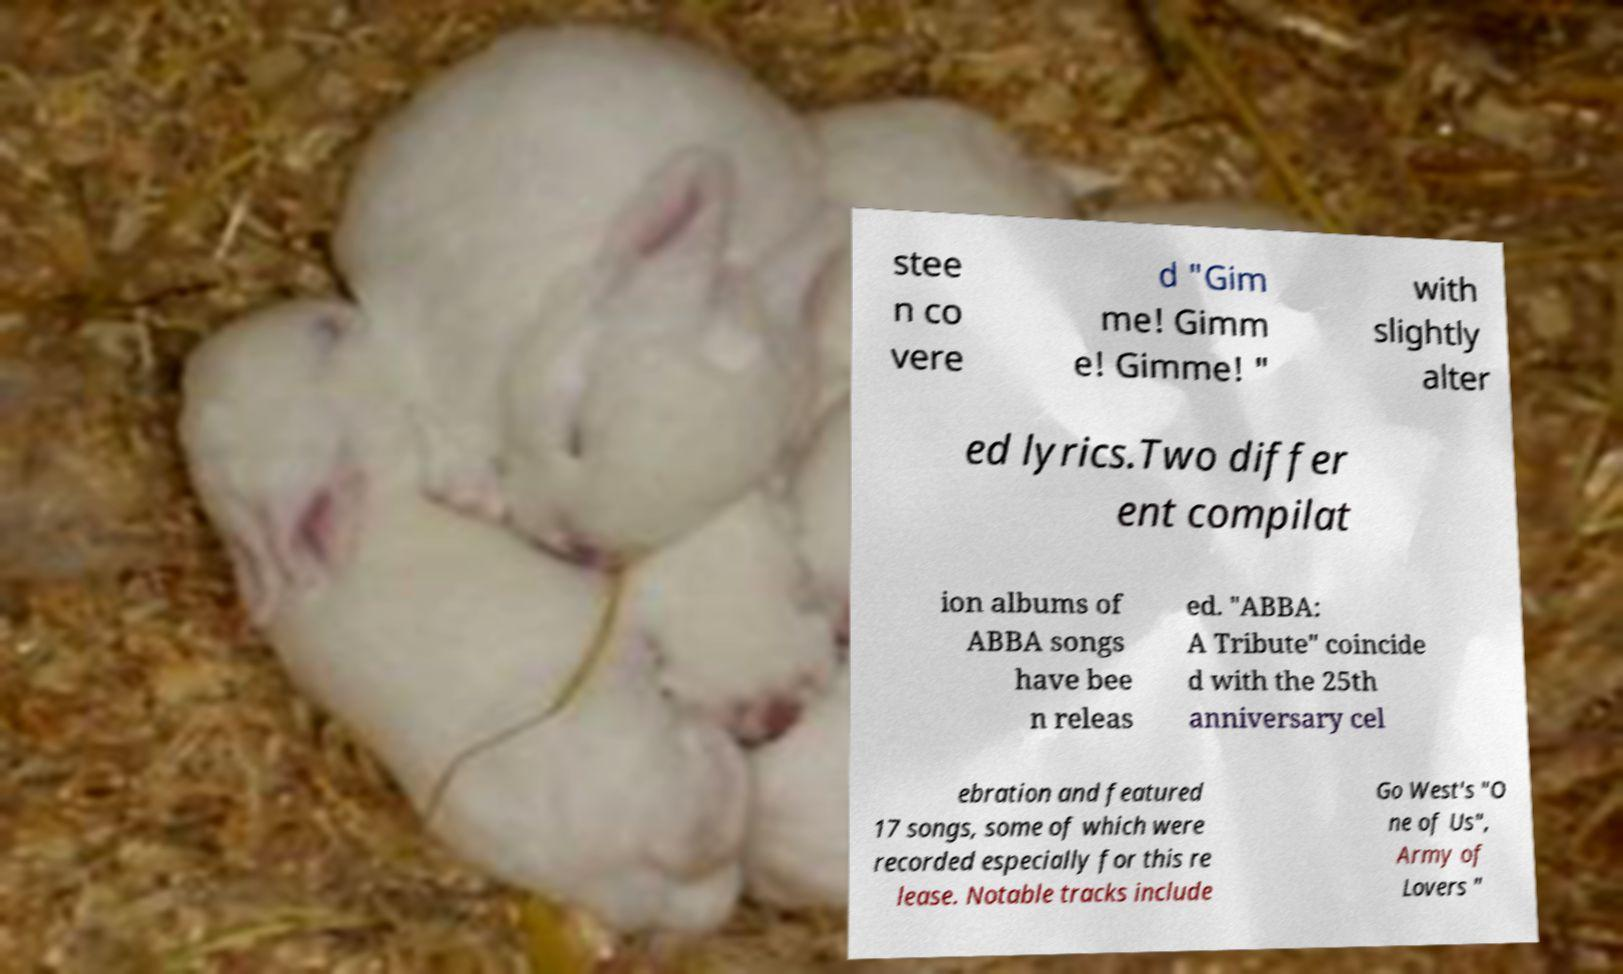What messages or text are displayed in this image? I need them in a readable, typed format. stee n co vere d "Gim me! Gimm e! Gimme! " with slightly alter ed lyrics.Two differ ent compilat ion albums of ABBA songs have bee n releas ed. "ABBA: A Tribute" coincide d with the 25th anniversary cel ebration and featured 17 songs, some of which were recorded especially for this re lease. Notable tracks include Go West's "O ne of Us", Army of Lovers " 